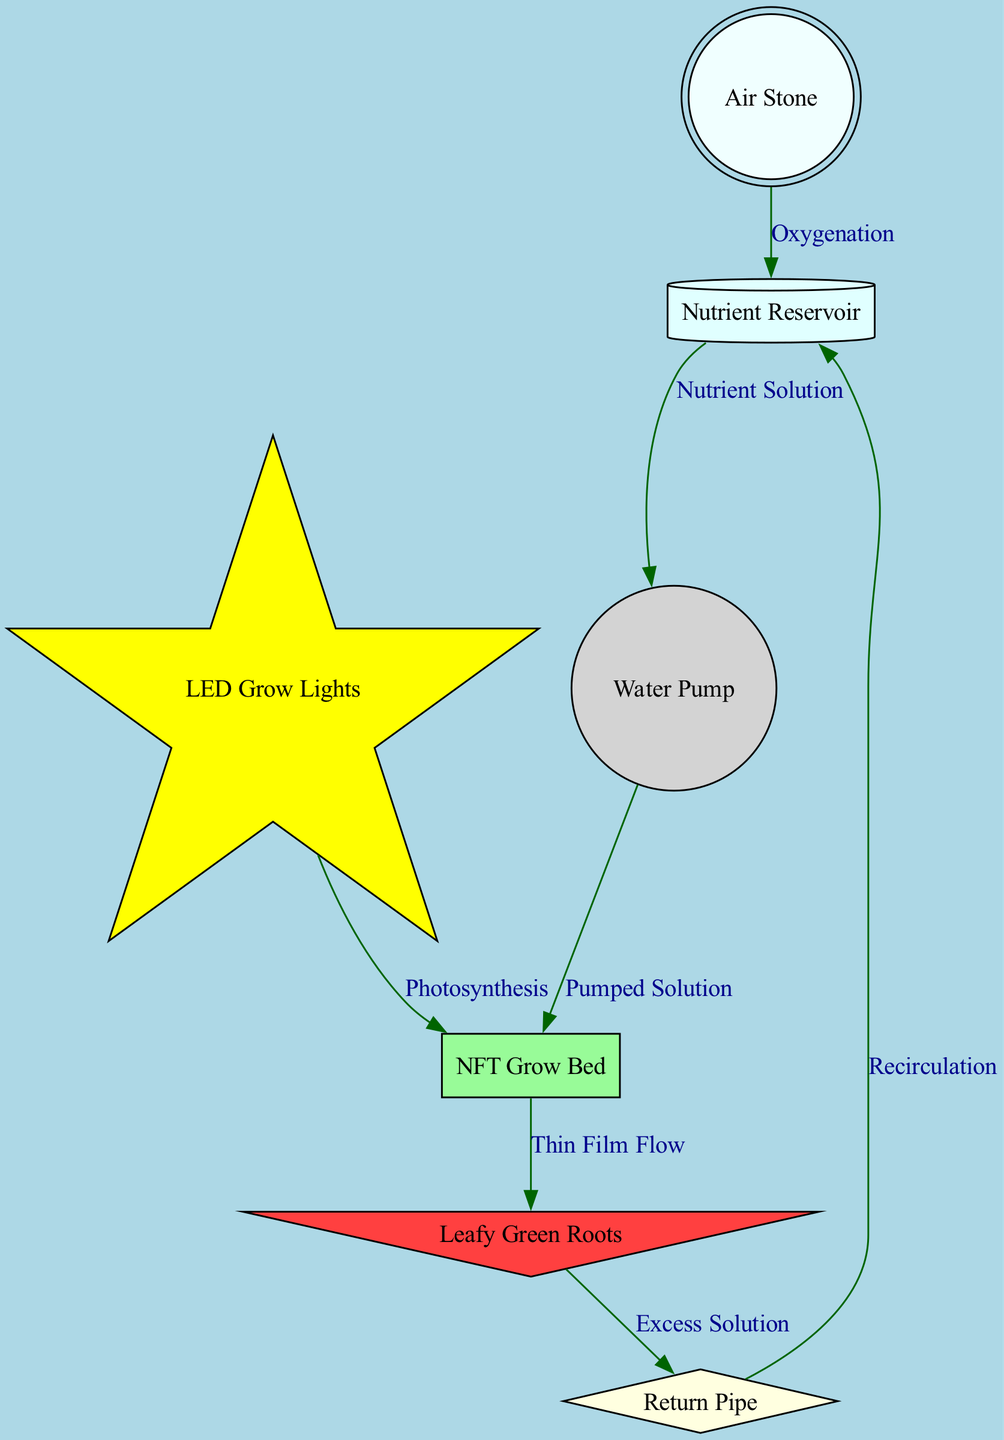What is the first component in the nutrient flow? The first component in the nutrient flow is the Nutrient Reservoir, which is depicted as the starting point of the nutrient solution.
Answer: Nutrient Reservoir How many nodes are there in the diagram? By counting the components displayed, there are a total of 7 nodes in the diagram representing different parts of the hydroponic system.
Answer: 7 What is the substance that flows from the Pump to the Grow Bed? The substance flowing from the Pump to the Grow Bed is the Pumped Solution, which signifies that the solution is being actively moved to the grow bed.
Answer: Pumped Solution What do the Leafy Green Roots send out as excess? The Leafy Green Roots send out Excess Solution, indicating the leftover nutrient solution that is not absorbed by the roots.
Answer: Excess Solution Which component is responsible for oxygenation? The component responsible for oxygenation in the system is the Air Stone, as it is indicated to provide oxygen to the reservoir.
Answer: Air Stone How does the nutrient solution return to the reservoir? The nutrient solution returns to the reservoir via the Return Pipe through a process called Recirculation, which is essential for maintaining nutrient availability.
Answer: Recirculation What is the role of LED Grow Lights in the system? The role of the LED Grow Lights is to provide light for Photosynthesis, ensuring that the leafy greens can produce energy from light.
Answer: Photosynthesis Which component connects the Leafy Green Roots to the Return Pipe? The connection from Leafy Green Roots to the Return Pipe is through the Thin Film Flow, which represents the movement of the nutrient solution that has interacted with the roots.
Answer: Thin Film Flow What color represents the Grow Bed in the diagram? The Grow Bed is represented in pale green, indicating its role in nurturing the plants through the nutrient film technique.
Answer: Pale green 